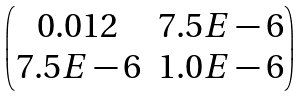Convert formula to latex. <formula><loc_0><loc_0><loc_500><loc_500>\begin{pmatrix} 0 . 0 1 2 & 7 . 5 E - 6 \\ 7 . 5 E - 6 & 1 . 0 E - 6 \end{pmatrix}</formula> 